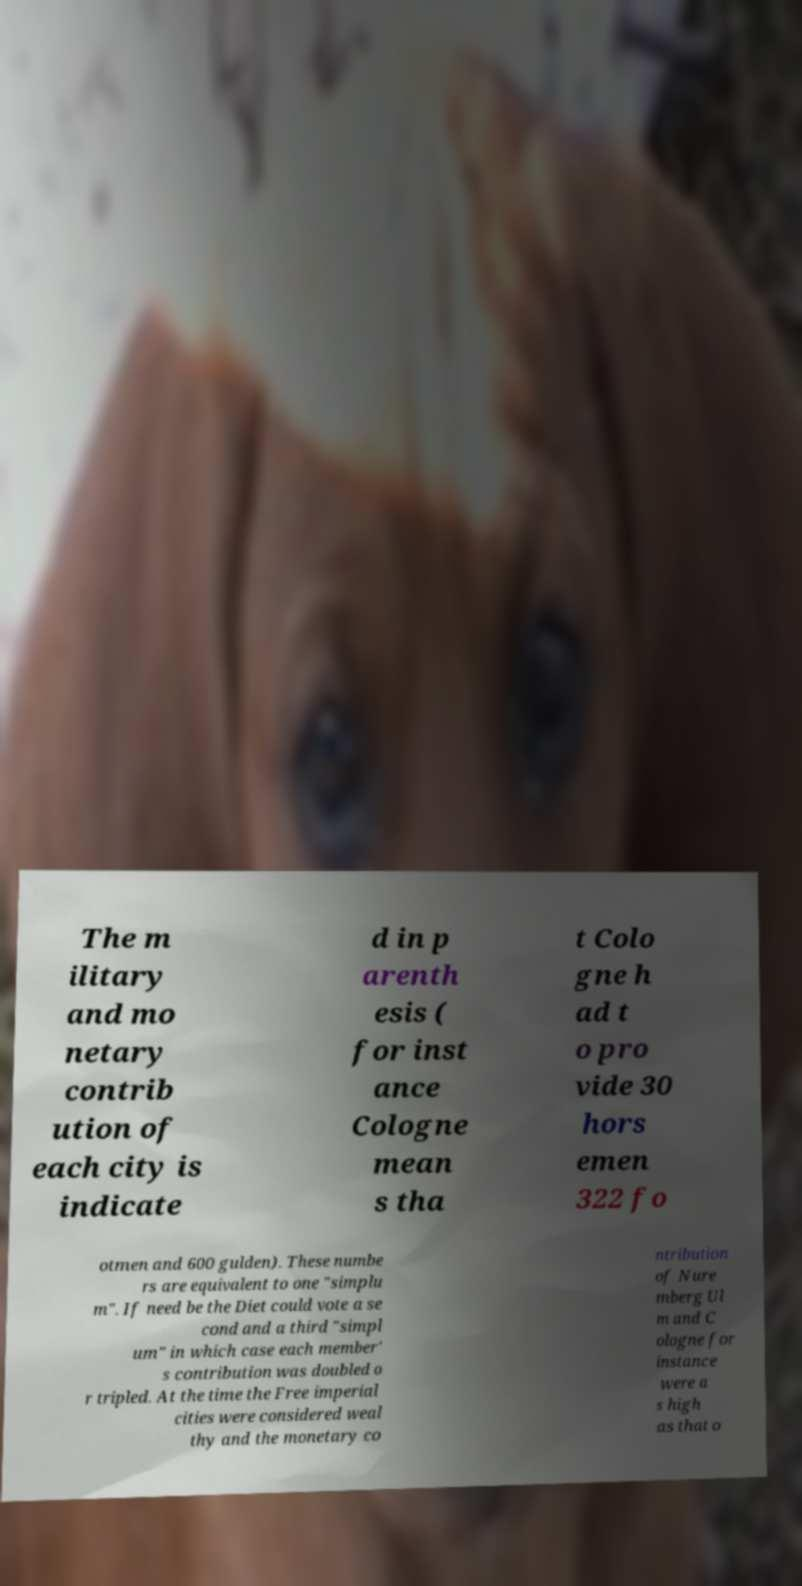Please read and relay the text visible in this image. What does it say? The m ilitary and mo netary contrib ution of each city is indicate d in p arenth esis ( for inst ance Cologne mean s tha t Colo gne h ad t o pro vide 30 hors emen 322 fo otmen and 600 gulden). These numbe rs are equivalent to one "simplu m". If need be the Diet could vote a se cond and a third "simpl um" in which case each member' s contribution was doubled o r tripled. At the time the Free imperial cities were considered weal thy and the monetary co ntribution of Nure mberg Ul m and C ologne for instance were a s high as that o 